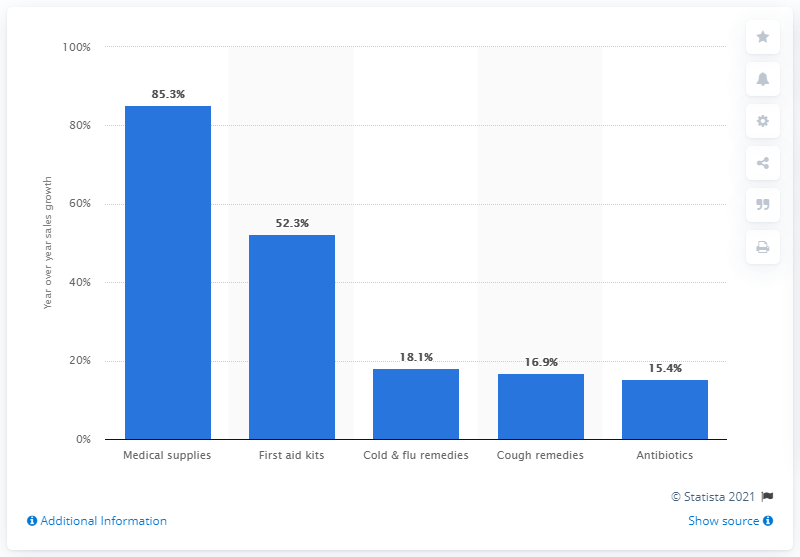Mention a couple of crucial points in this snapshot. The sales value of medical supplies increased by 85.3% in the week ending February 29, 2020. 